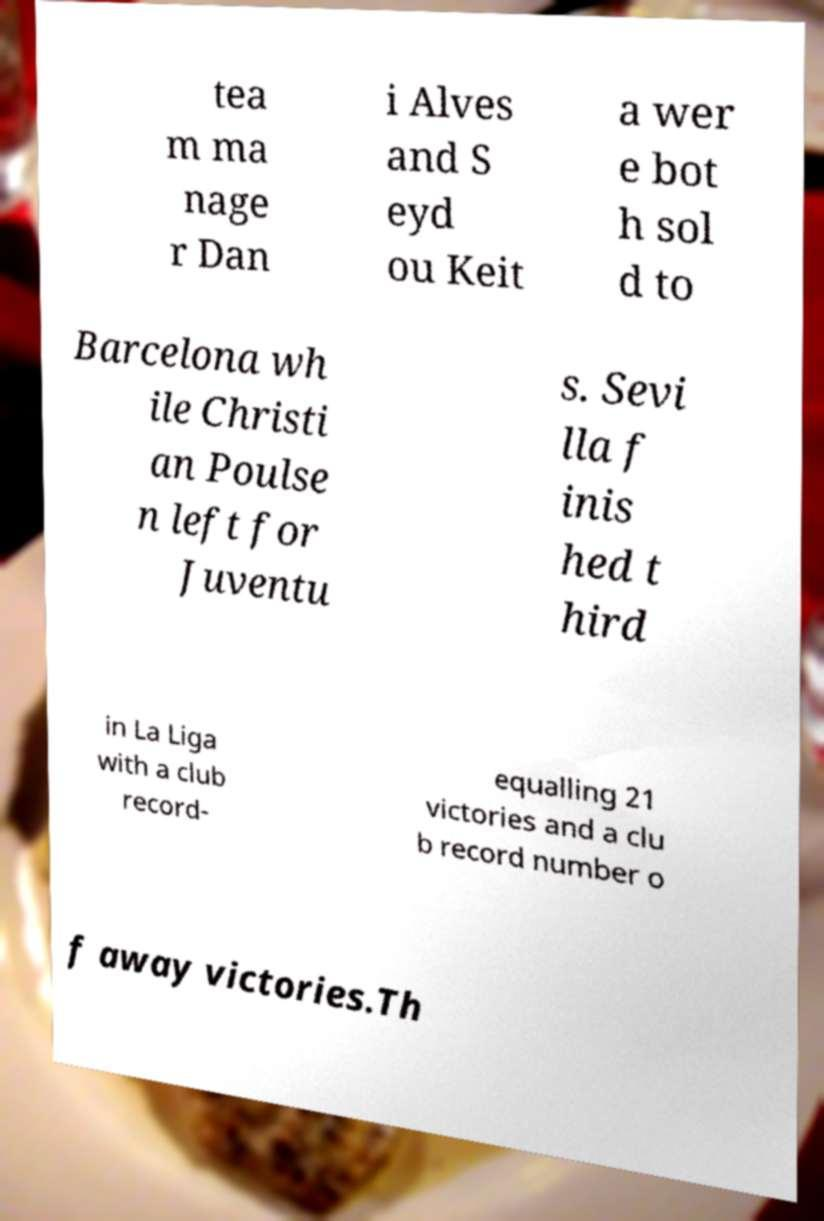Could you extract and type out the text from this image? tea m ma nage r Dan i Alves and S eyd ou Keit a wer e bot h sol d to Barcelona wh ile Christi an Poulse n left for Juventu s. Sevi lla f inis hed t hird in La Liga with a club record- equalling 21 victories and a clu b record number o f away victories.Th 